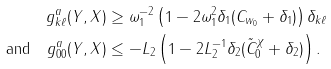Convert formula to latex. <formula><loc_0><loc_0><loc_500><loc_500>g _ { k \ell } ^ { a } ( Y , X ) & \geq \omega _ { 1 } ^ { - 2 } \left ( 1 - 2 \omega _ { 1 } ^ { 2 } \delta _ { 1 } ( C _ { w _ { 0 } } + \delta _ { 1 } ) \right ) \delta _ { k \ell } \\ \text {and} \quad g _ { 0 0 } ^ { a } ( Y , X ) & \leq - L _ { 2 } \left ( 1 - 2 L _ { 2 } ^ { - 1 } \delta _ { 2 } ( \tilde { C } _ { 0 } ^ { \chi } + \delta _ { 2 } ) \right ) .</formula> 